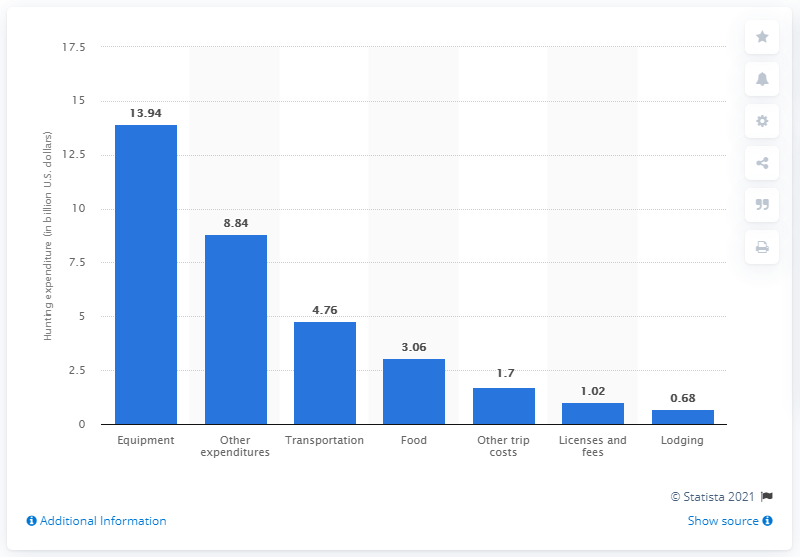Identify some key points in this picture. In 2011, the United States spent approximately $4.76 billion on transportation for hunting trips. 